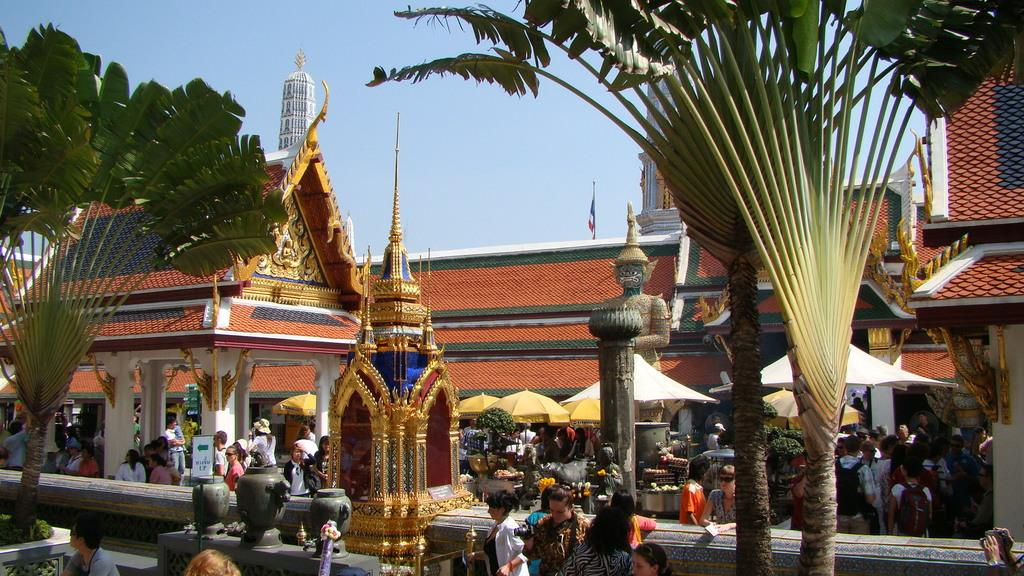What type of structure is present in the image? There is a building in the image. What other objects can be seen in the image? There are plants, a sculpture, tents, a flag, and a group of people in the image. What might be used for displaying information or advertisements? There are boards in the image that could be used for displaying information or advertisements. What is visible at the top of the image? The sky is visible at the top of the image. What thought is the mom having while looking at the sign in the image? There is no sign or mom present in the image, so it is not possible to answer that question. 